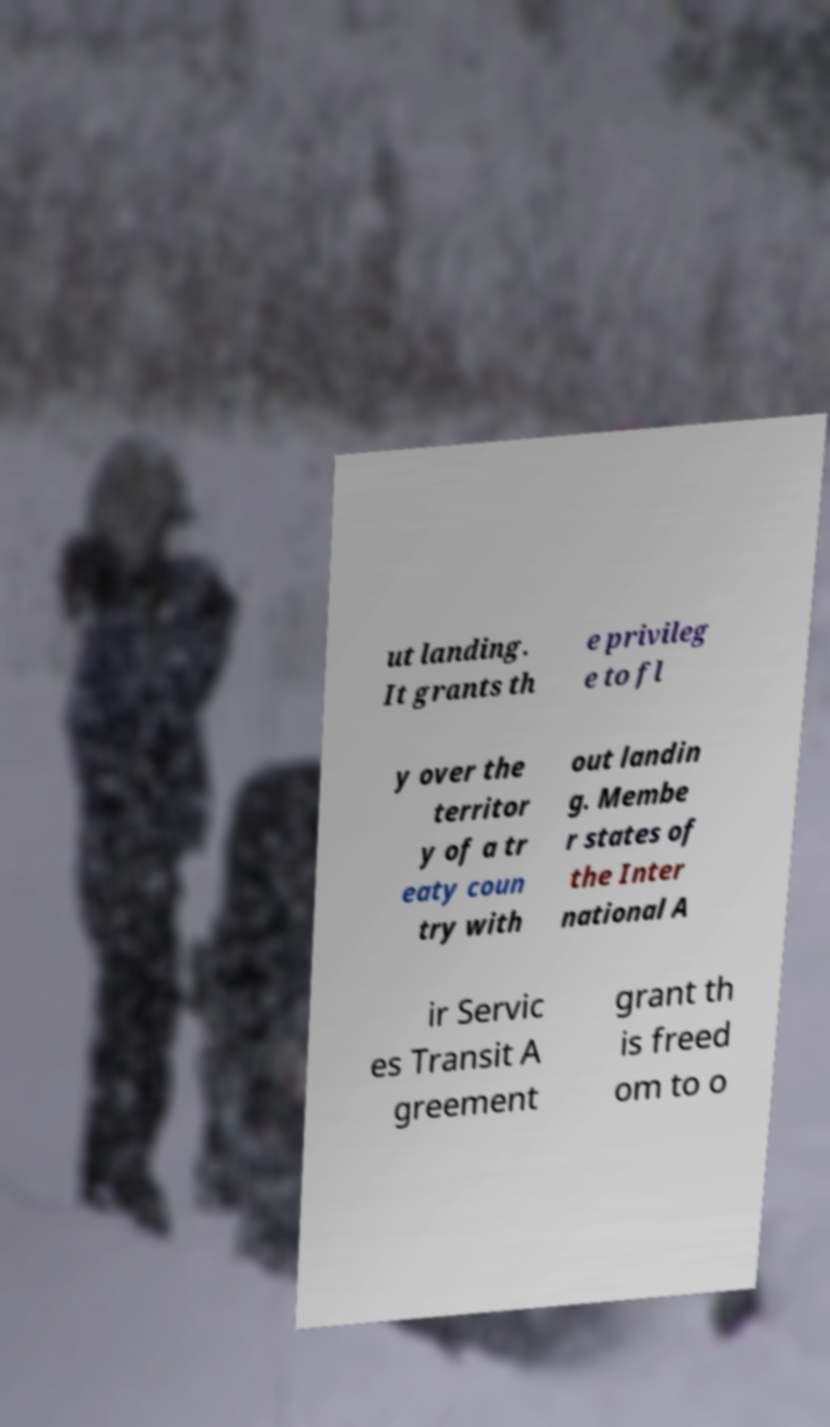What messages or text are displayed in this image? I need them in a readable, typed format. ut landing. It grants th e privileg e to fl y over the territor y of a tr eaty coun try with out landin g. Membe r states of the Inter national A ir Servic es Transit A greement grant th is freed om to o 